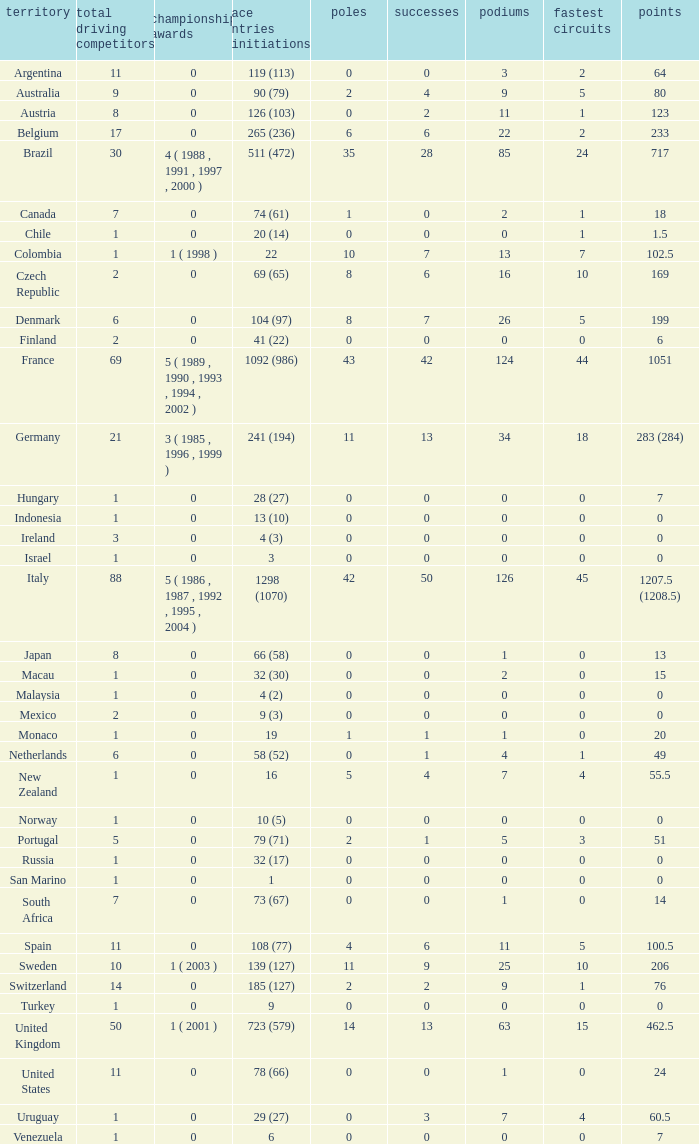How many fastest laps for the nation with 32 (30) entries and starts and fewer than 2 podiums? None. 